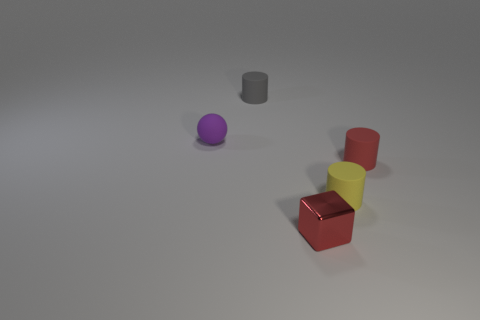Are there any other things that are the same size as the red rubber cylinder?
Keep it short and to the point. Yes. What number of small red cubes are behind the red thing that is behind the small object that is in front of the yellow matte cylinder?
Your answer should be very brief. 0. Do the small purple object and the yellow object have the same shape?
Your response must be concise. No. Is the red thing that is on the right side of the red metal object made of the same material as the tiny red object on the left side of the tiny yellow thing?
Your answer should be very brief. No. What number of things are either small matte cylinders to the left of the small red metal object or tiny cylinders to the left of the red metal thing?
Ensure brevity in your answer.  1. Is there any other thing that is the same shape as the purple thing?
Your answer should be very brief. No. How many small gray rubber cylinders are there?
Offer a terse response. 1. Is there a yellow cylinder of the same size as the red rubber thing?
Offer a very short reply. Yes. Are the tiny ball and the cylinder that is behind the red rubber cylinder made of the same material?
Your answer should be compact. Yes. There is a small thing in front of the yellow rubber object; what is its material?
Provide a succinct answer. Metal. 